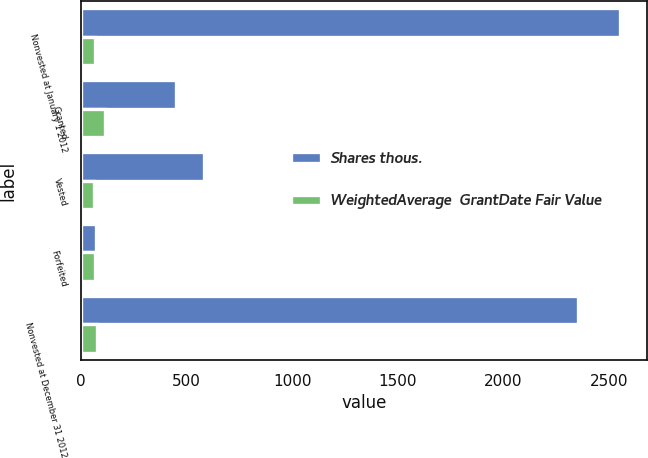Convert chart. <chart><loc_0><loc_0><loc_500><loc_500><stacked_bar_chart><ecel><fcel>Nonvested at January 1 2012<fcel>Granted<fcel>Vested<fcel>Forfeited<fcel>Nonvested at December 31 2012<nl><fcel>Shares thous.<fcel>2556<fcel>451<fcel>581<fcel>71<fcel>2355<nl><fcel>WeightedAverage  GrantDate Fair Value<fcel>63.2<fcel>114.51<fcel>62.1<fcel>64.18<fcel>73.27<nl></chart> 